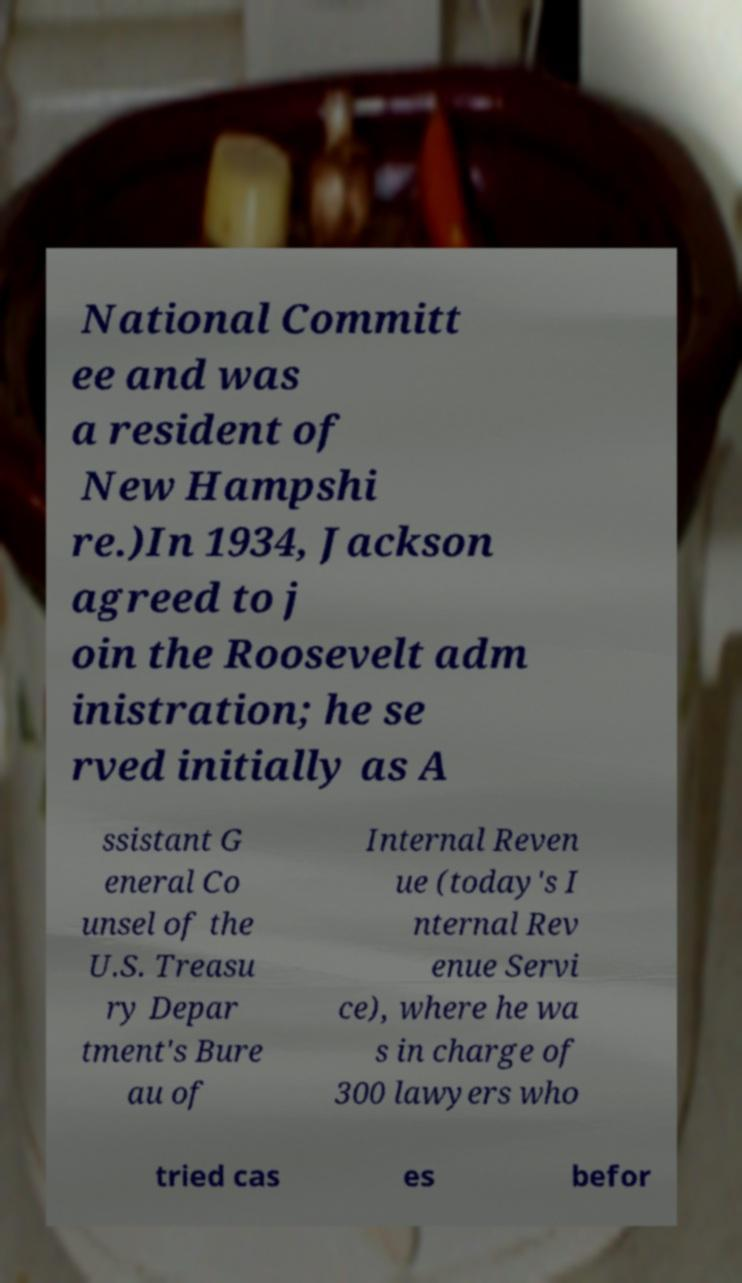Could you assist in decoding the text presented in this image and type it out clearly? National Committ ee and was a resident of New Hampshi re.)In 1934, Jackson agreed to j oin the Roosevelt adm inistration; he se rved initially as A ssistant G eneral Co unsel of the U.S. Treasu ry Depar tment's Bure au of Internal Reven ue (today's I nternal Rev enue Servi ce), where he wa s in charge of 300 lawyers who tried cas es befor 